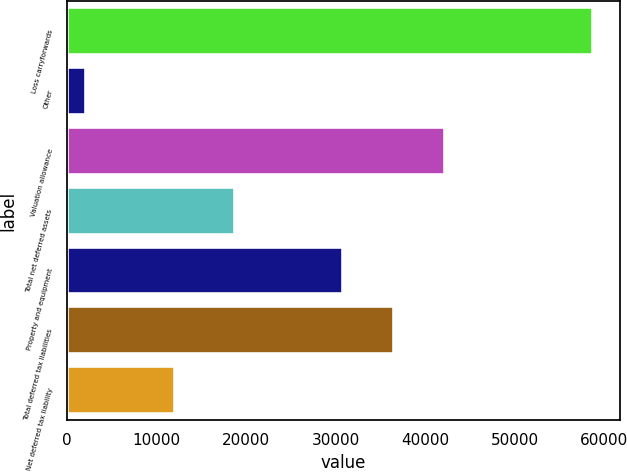Convert chart. <chart><loc_0><loc_0><loc_500><loc_500><bar_chart><fcel>Loss carryforwards<fcel>Other<fcel>Valuation allowance<fcel>Total net deferred assets<fcel>Property and equipment<fcel>Total deferred tax liabilities<fcel>Net deferred tax liability<nl><fcel>58789<fcel>2106<fcel>42205.6<fcel>18741<fcel>30869<fcel>36537.3<fcel>12128<nl></chart> 